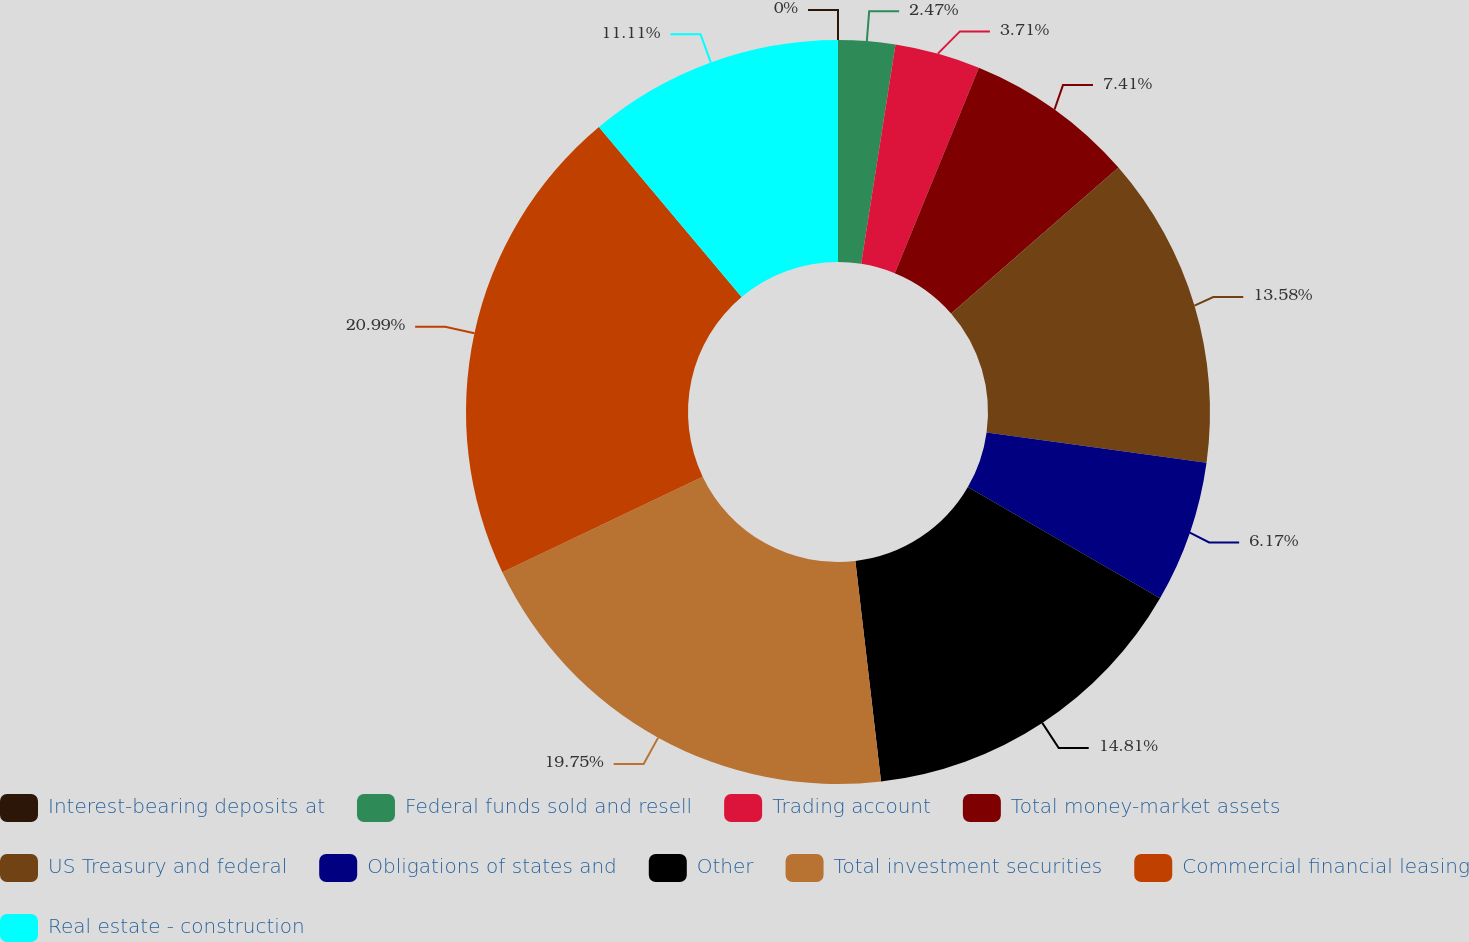Convert chart to OTSL. <chart><loc_0><loc_0><loc_500><loc_500><pie_chart><fcel>Interest-bearing deposits at<fcel>Federal funds sold and resell<fcel>Trading account<fcel>Total money-market assets<fcel>US Treasury and federal<fcel>Obligations of states and<fcel>Other<fcel>Total investment securities<fcel>Commercial financial leasing<fcel>Real estate - construction<nl><fcel>0.0%<fcel>2.47%<fcel>3.71%<fcel>7.41%<fcel>13.58%<fcel>6.17%<fcel>14.81%<fcel>19.75%<fcel>20.98%<fcel>11.11%<nl></chart> 